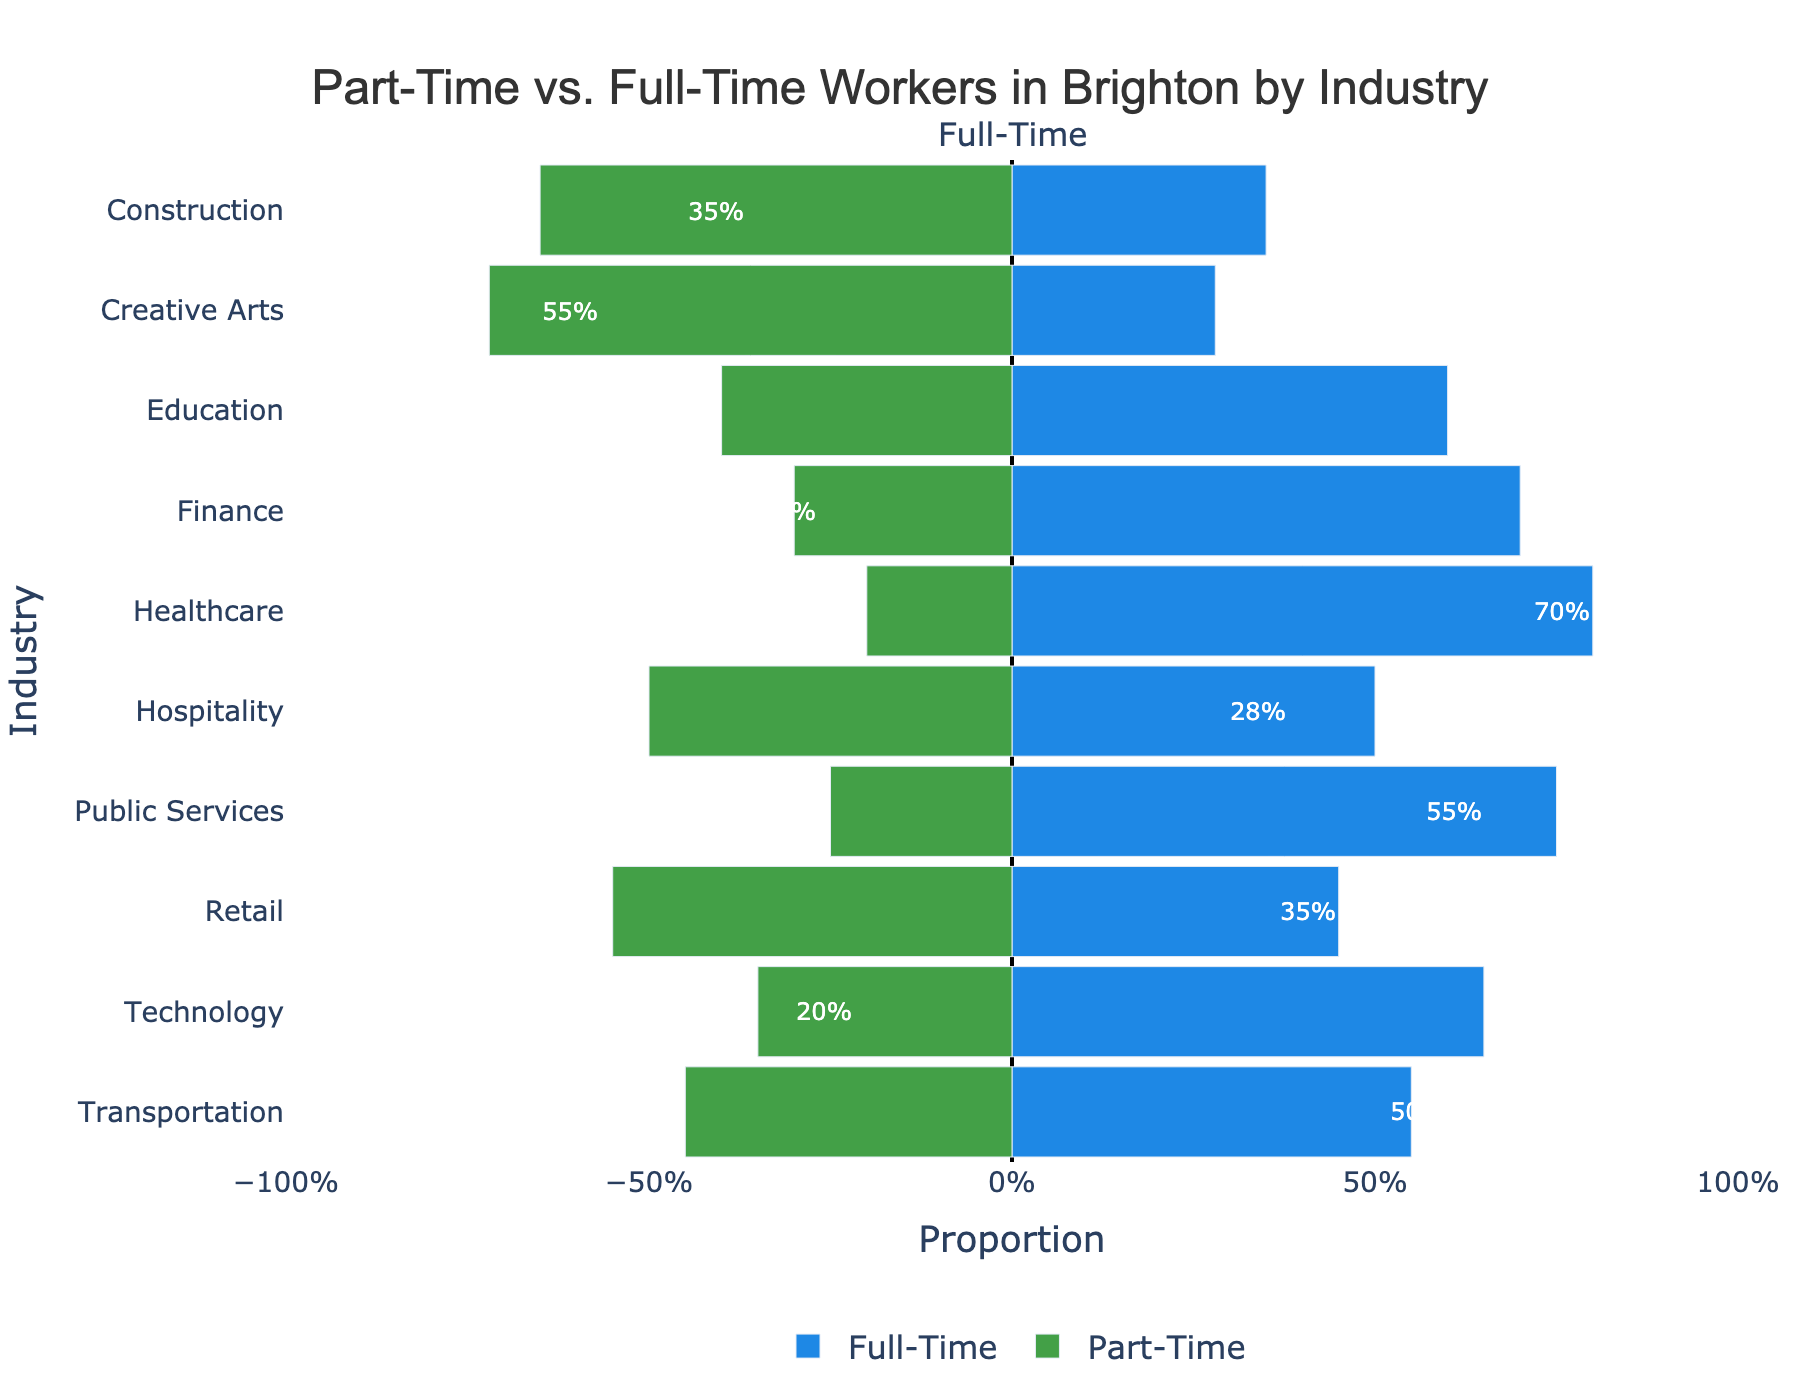What industry has the highest proportion of part-time workers? To determine which industry has the highest proportion of part-time workers, look for the bar with the most extended length to the left. In this figure, Hospitality has the longest part-time bar (72%).
Answer: Hospitality What is the difference in proportion between full-time and part-time workers in Education? In the Education industry, the proportion of full-time workers is 60%, and the proportion of part-time workers is 40%. The difference is calculated as 60% - 40%.
Answer: 20% Which industry has an equal proportion of part-time and full-time workers? An equal proportion of part-time and full-time workers would be represented by bars of equal length in both directions. Transportation has an equal proportion of 50% each for both worker types.
Answer: Transportation How does the proportion of part-time workers in Technology compare to that in Healthcare? In Technology, the part-time proportion is 20%, and in Healthcare, it is 30%. Comparing these values shows that Healthcare has a higher proportion of part-time workers than Technology.
Answer: Healthcare What is the average proportion of full-time workers across all the industries? Summing the proportions of full-time workers across all industries and then dividing by the number of industries: (35% + 28% + 60% + 70% + 80% + 50% + 75% + 45% + 65% + 55%) / 10 = 56.3%
Answer: 56.3% Which industry has the lowest proportion of full-time workers? To find the industry with the lowest full-time worker proportion, look for the shortest bar extending to the right. Hospitality has the lowest proportion of full-time workers at 28%.
Answer: Hospitality Are there more industries where part-time workers are the majority or industries where full-time workers are the majority? Count the number of industries with part-time worker proportions exceeding 50% and compare it with the count of industries with full-time worker proportions exceeding 50%. There are four industries with part-time majority (Retail, Hospitality, Creative Arts, Transportation) and six with full-time majority (Education, Healthcare, Technology, Finance, Construction, Public Services).
Answer: Full-time majority What is the total proportion of full-time workers in the Retail and Finance industries combined? The proportion of full-time workers in Retail is 35%, and in Finance, it is 75%. Adding these together gives 35% + 75%.
Answer: 110% Which industry shows the closest to an even split between part-time and full-time workers but doesn't have an exactly equal split? To find the industry closest to an even split but not exactly equal, look for the industry where the two bars' lengths are most similar but not identical. Public Services, with 45% part-time and 55% full-time, fits this description.
Answer: Public Services 